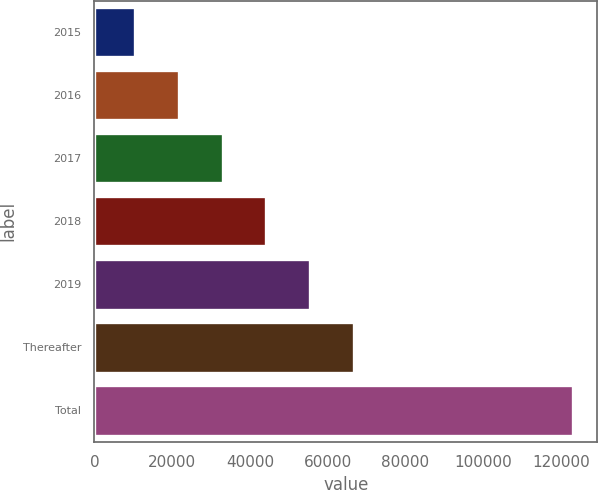<chart> <loc_0><loc_0><loc_500><loc_500><bar_chart><fcel>2015<fcel>2016<fcel>2017<fcel>2018<fcel>2019<fcel>Thereafter<fcel>Total<nl><fcel>10441<fcel>21710.1<fcel>32979.2<fcel>44248.3<fcel>55517.4<fcel>66786.5<fcel>123132<nl></chart> 